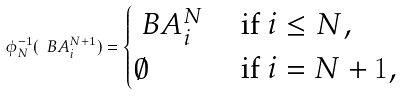Convert formula to latex. <formula><loc_0><loc_0><loc_500><loc_500>\phi _ { N } ^ { - 1 } ( \ B { A } _ { i } ^ { N + 1 } ) = \begin{cases} \ B { A } _ { i } ^ { N } & \text { if } i \leq N , \\ \emptyset & \text { if } i = N + 1 , \end{cases}</formula> 